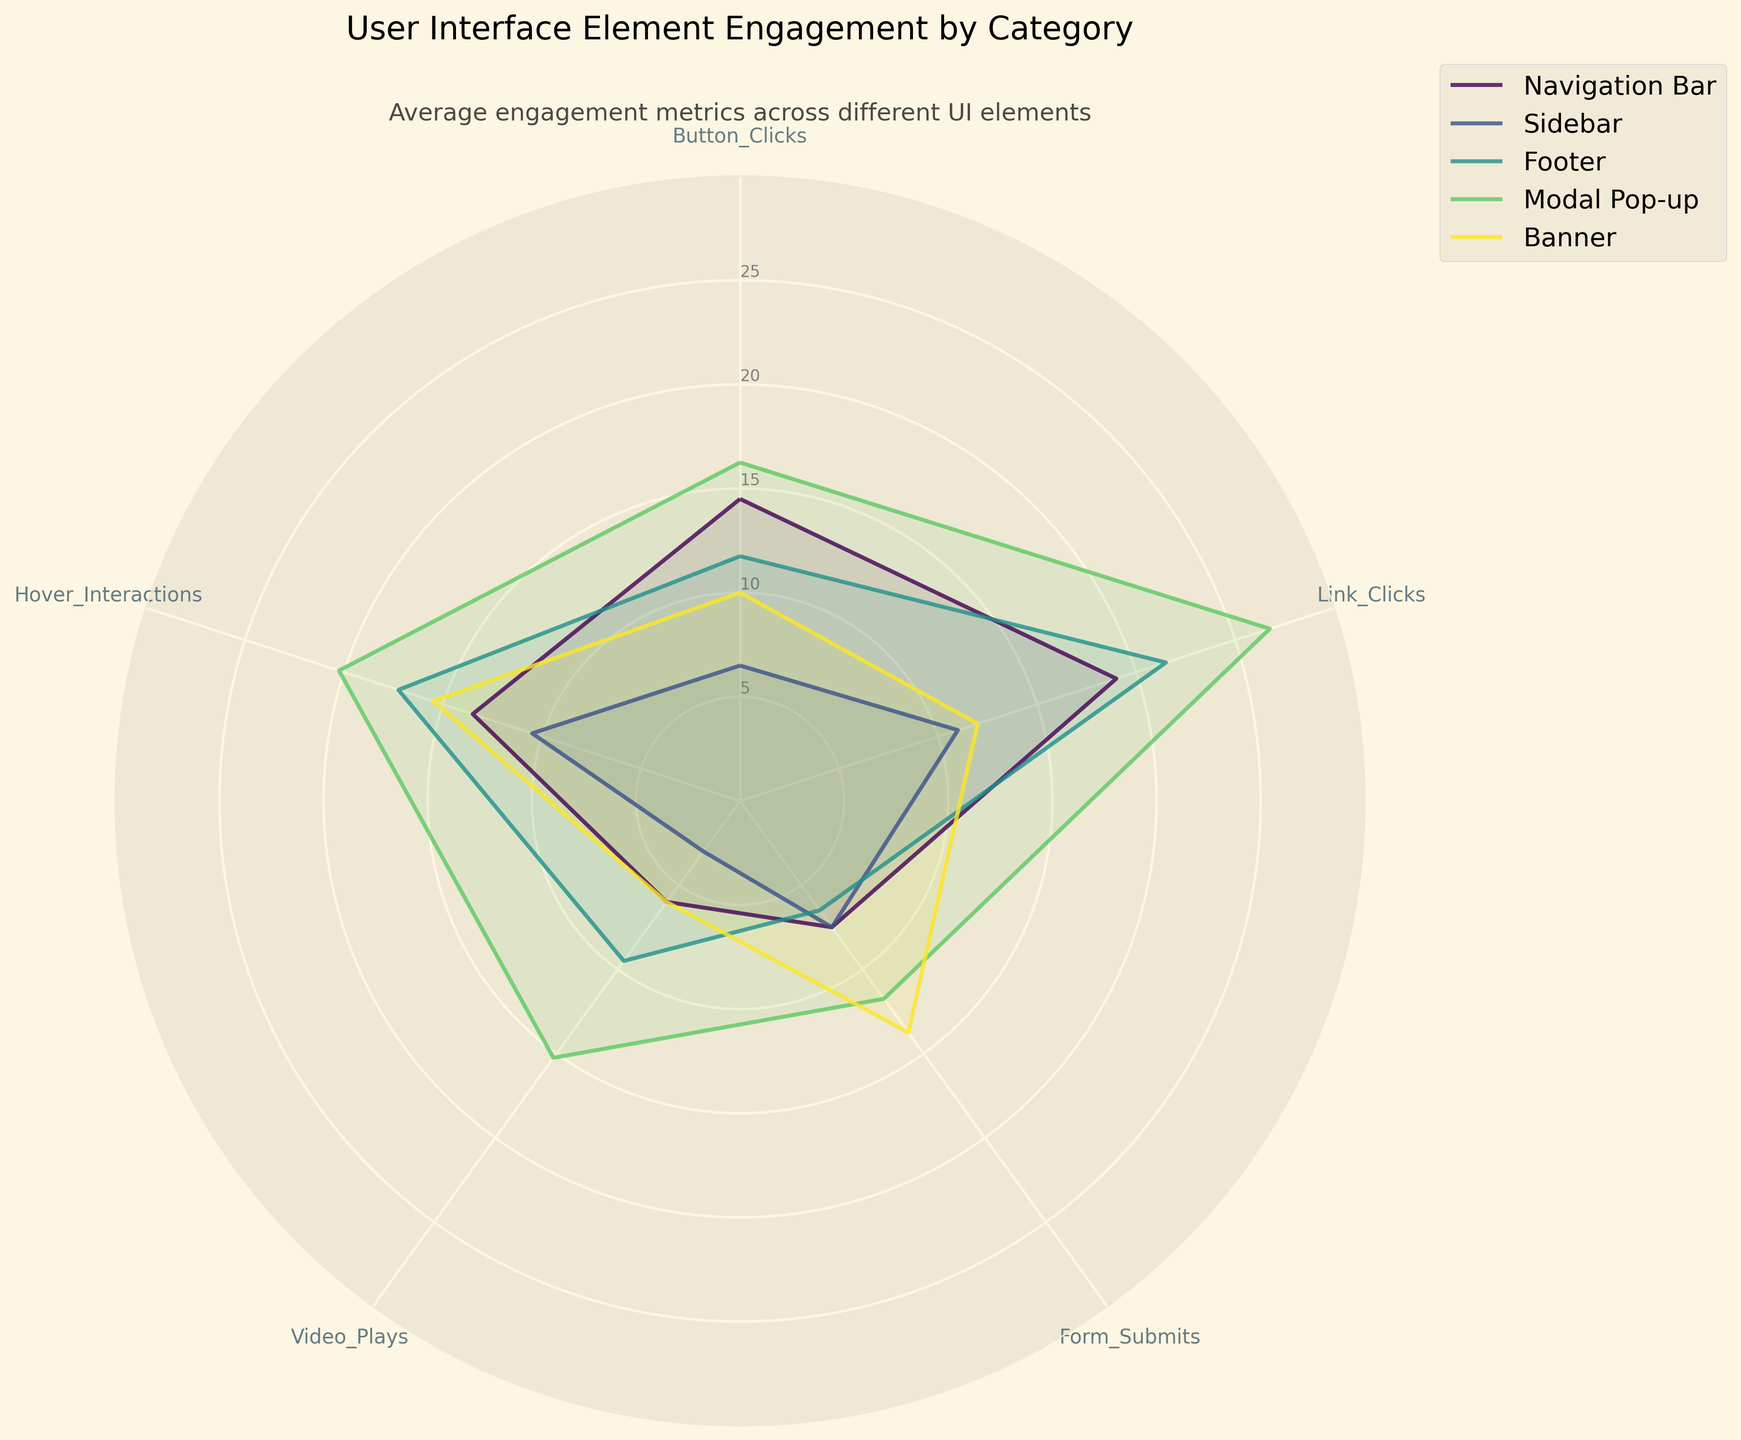How many categories of user interface elements are shown in the plot? Observe the number of distinct labels in the legend to count the categories.
Answer: 5 What is the title of the plot? Read the text at the top of the plot.
Answer: User Interface Element Engagement by Category Which metric is at the top of the radar chart? Locate the labels around the perimeter/angles of the radar chart and identify the label at the topmost position.
Answer: Button_Clicks What is the average number of Form_Submits for Modal Pop-up? Identify the Modal Pop-up line on the chart, find the section corresponding to Form_Submits, and read the radial value.
Answer: 6.5 Compare the Video Plays for Navigation Bar and Banner categories. Which one is higher? Identify the radar lines for Navigation Bar and Banner, locate the Video_Plays metric section, and compare their radial values.
Answer: Navigation Bar Which category has the highest Link Clicks? Observe the maximum radial value for the Link_Clicks section among all categories.
Answer: Navigation Bar Calculate the difference in average Button Clicks between Sidebar and Footer categories. Identify the Button_Clicks values for Sidebar and Footer categories, and subtract the Footer value from the Sidebar value.
Answer: 4 Which category has the lowest Hover Interactions? Observe the minimum radial value for the Hover_Interactions section among all categories.
Answer: Footer For Video Plays, is the value for Banner closer to Sidebar or Navigation Bar? Compare the radial values of Video_Plays for Banner, Sidebar, and Navigation Bar categories.
Answer: Navigation Bar What is the angle corresponding to the Form_Submits metric on the chart? Each metric is evenly spaced; compute the angle by dividing 360 (or 2π radians) by the number of metrics and multiplying by the metric index for Form_Submits.
Answer: 144 degrees (or 4π/5 radians) 